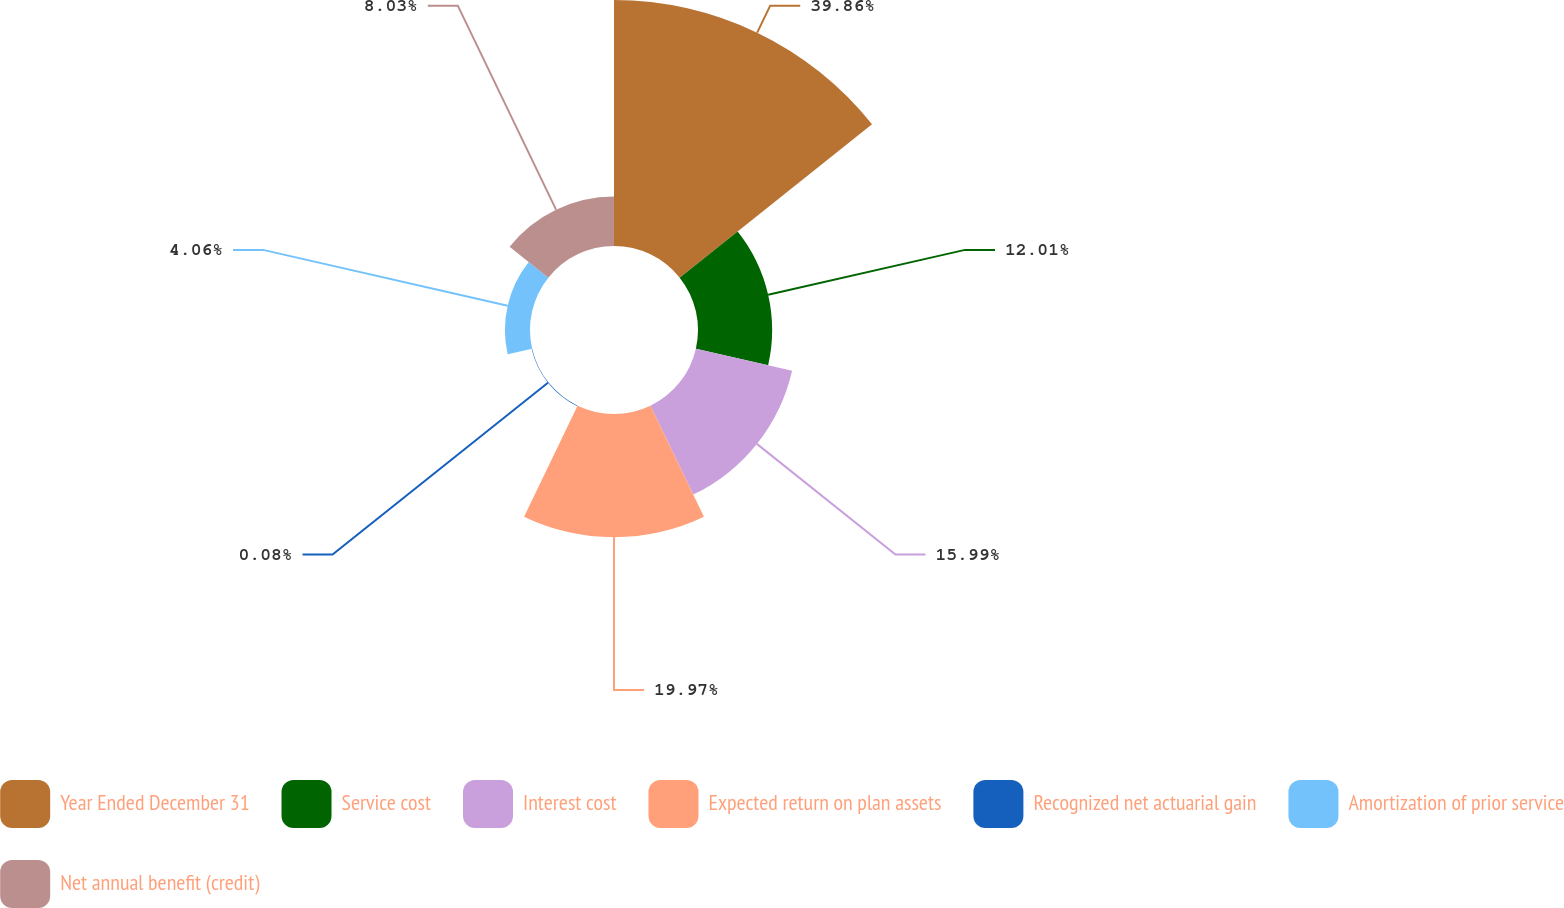<chart> <loc_0><loc_0><loc_500><loc_500><pie_chart><fcel>Year Ended December 31<fcel>Service cost<fcel>Interest cost<fcel>Expected return on plan assets<fcel>Recognized net actuarial gain<fcel>Amortization of prior service<fcel>Net annual benefit (credit)<nl><fcel>39.86%<fcel>12.01%<fcel>15.99%<fcel>19.97%<fcel>0.08%<fcel>4.06%<fcel>8.03%<nl></chart> 